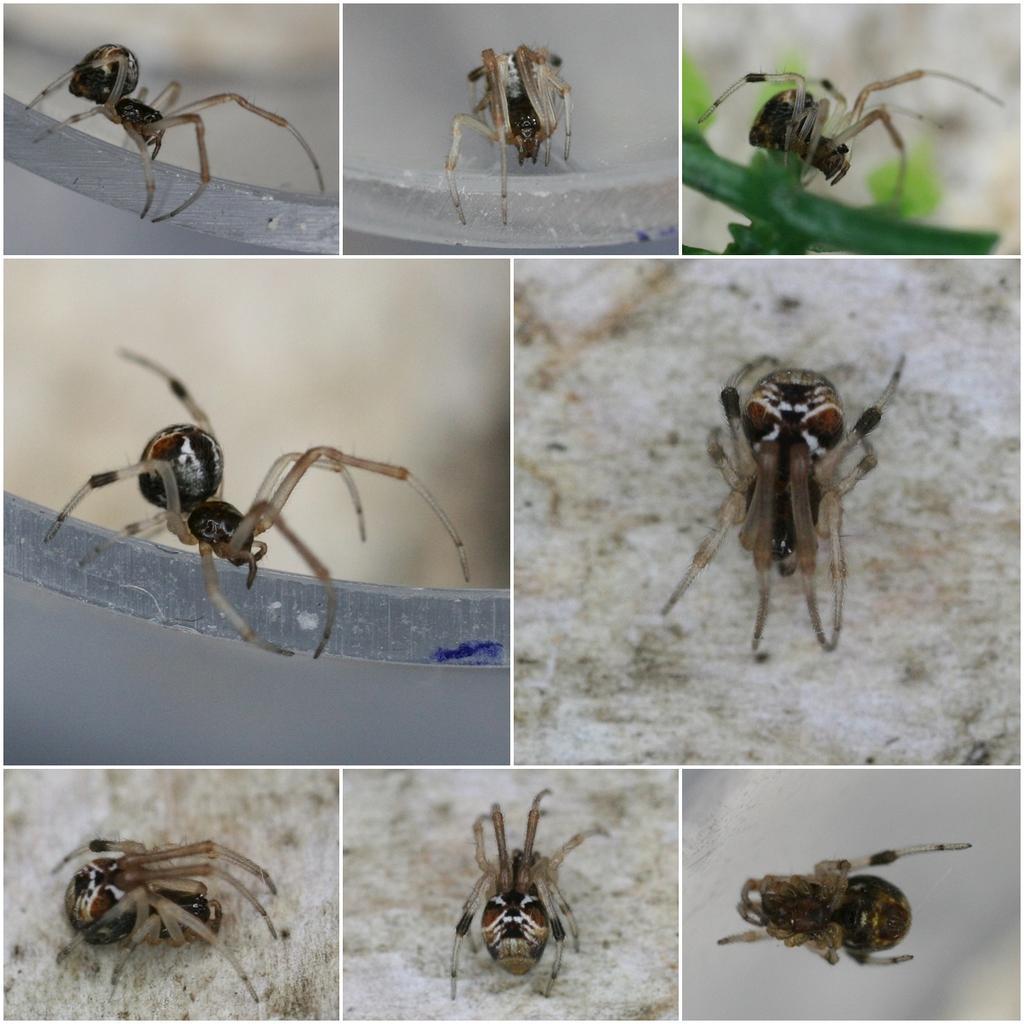Describe this image in one or two sentences. This is a collage image where I can see the spider in the white color background. 